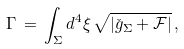<formula> <loc_0><loc_0><loc_500><loc_500>\Gamma \, = \, \int _ { \Sigma } d ^ { 4 } \xi \, \sqrt { | \check { g } _ { \Sigma } + \mathcal { F } | } \, ,</formula> 